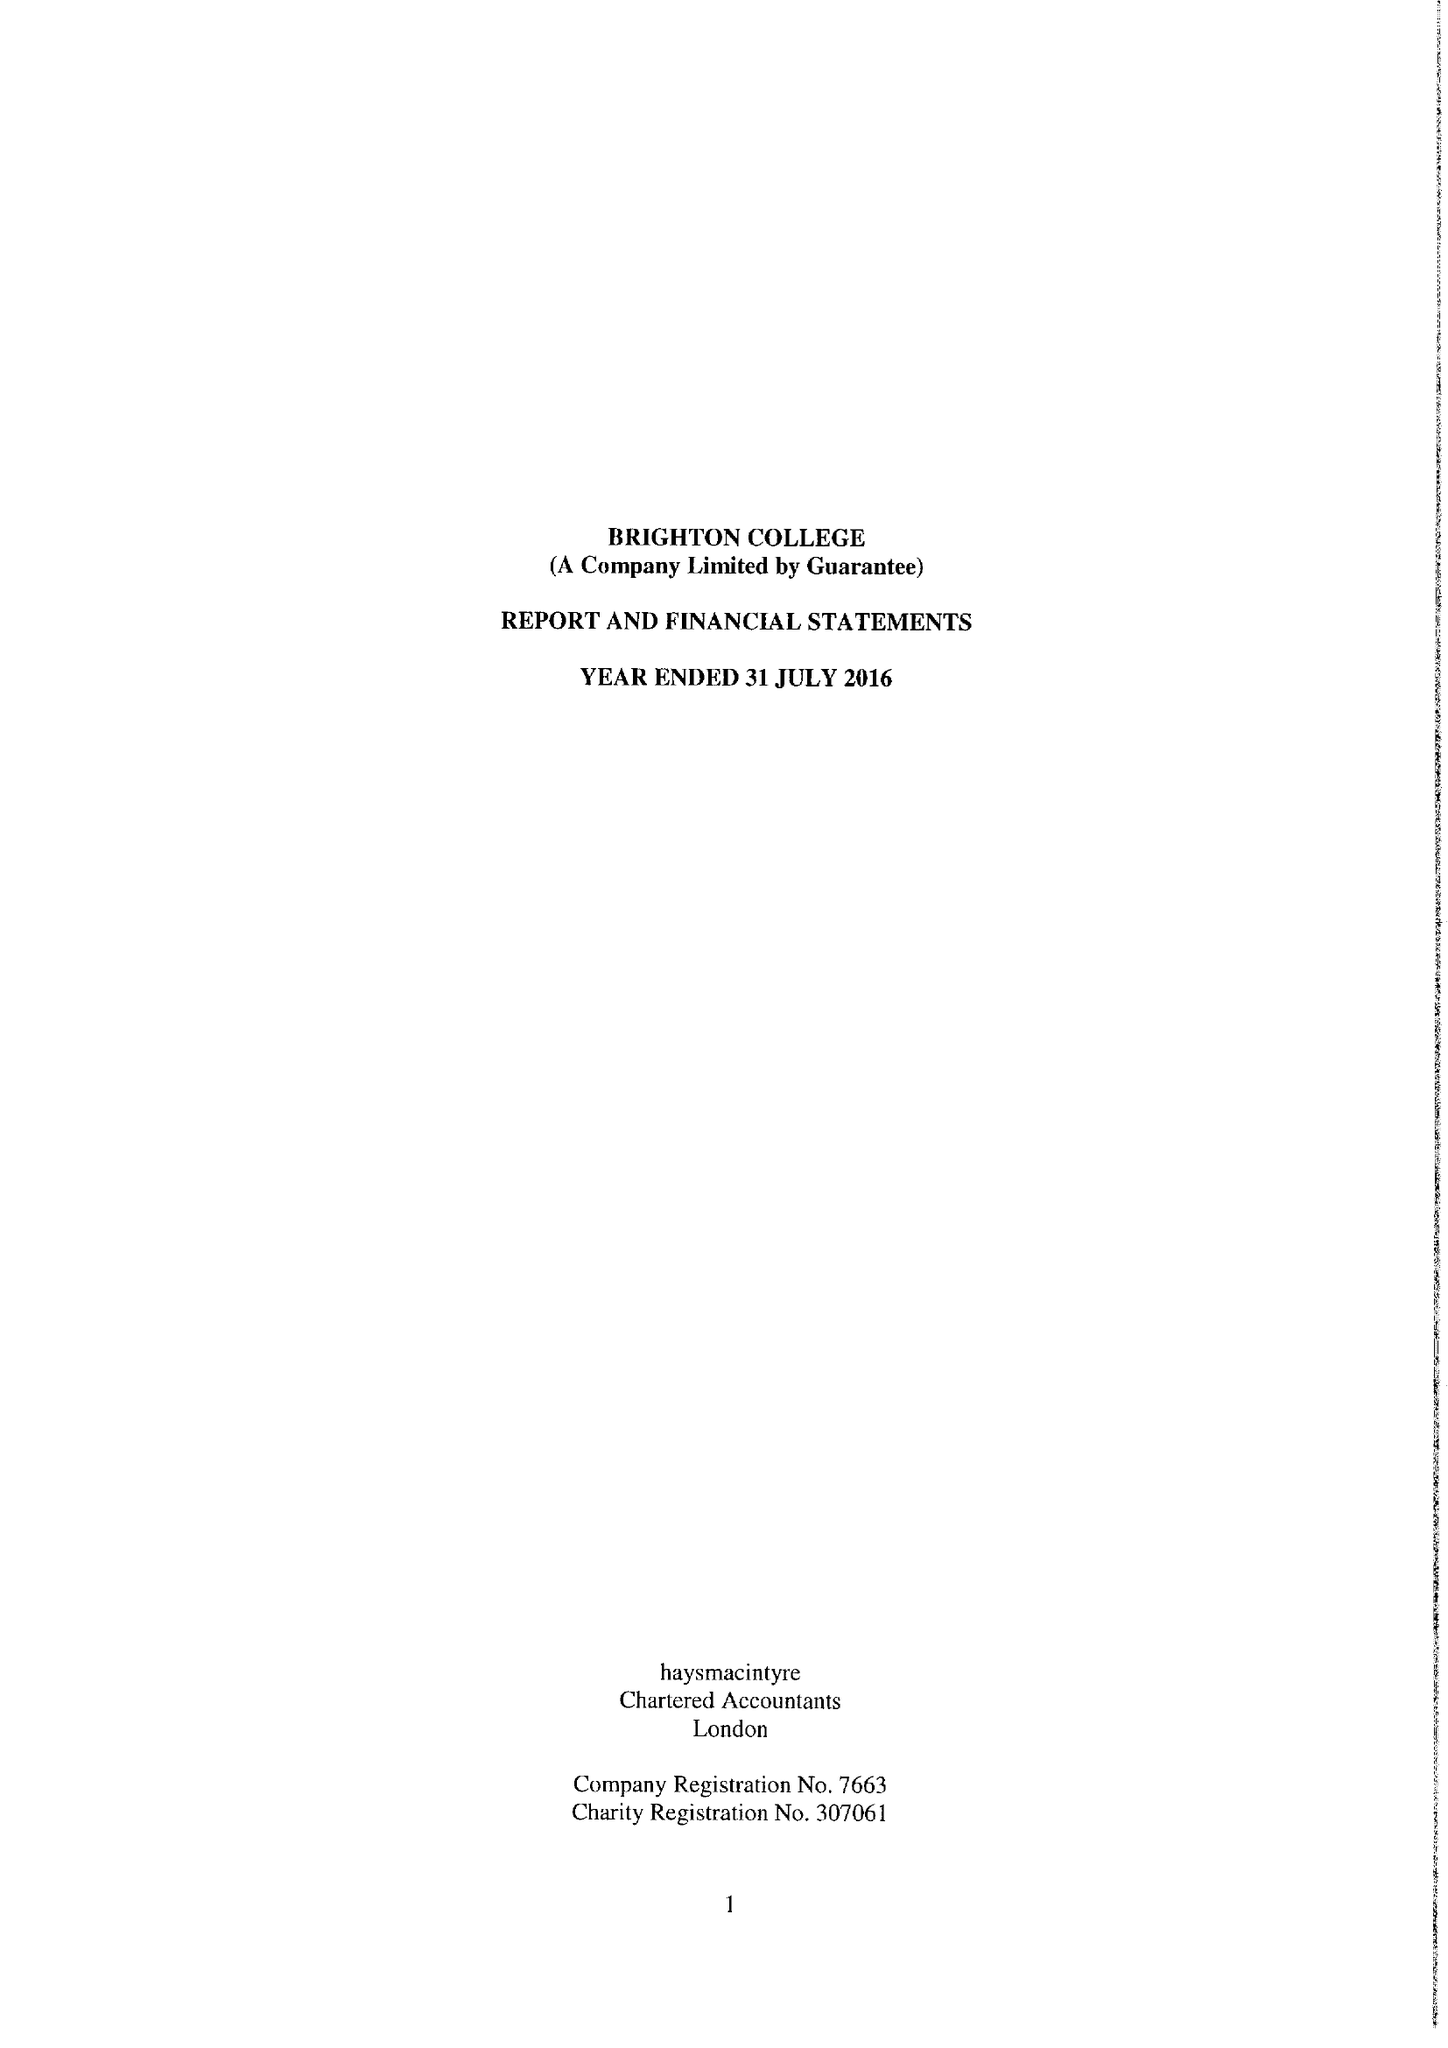What is the value for the report_date?
Answer the question using a single word or phrase. 2016-07-31 